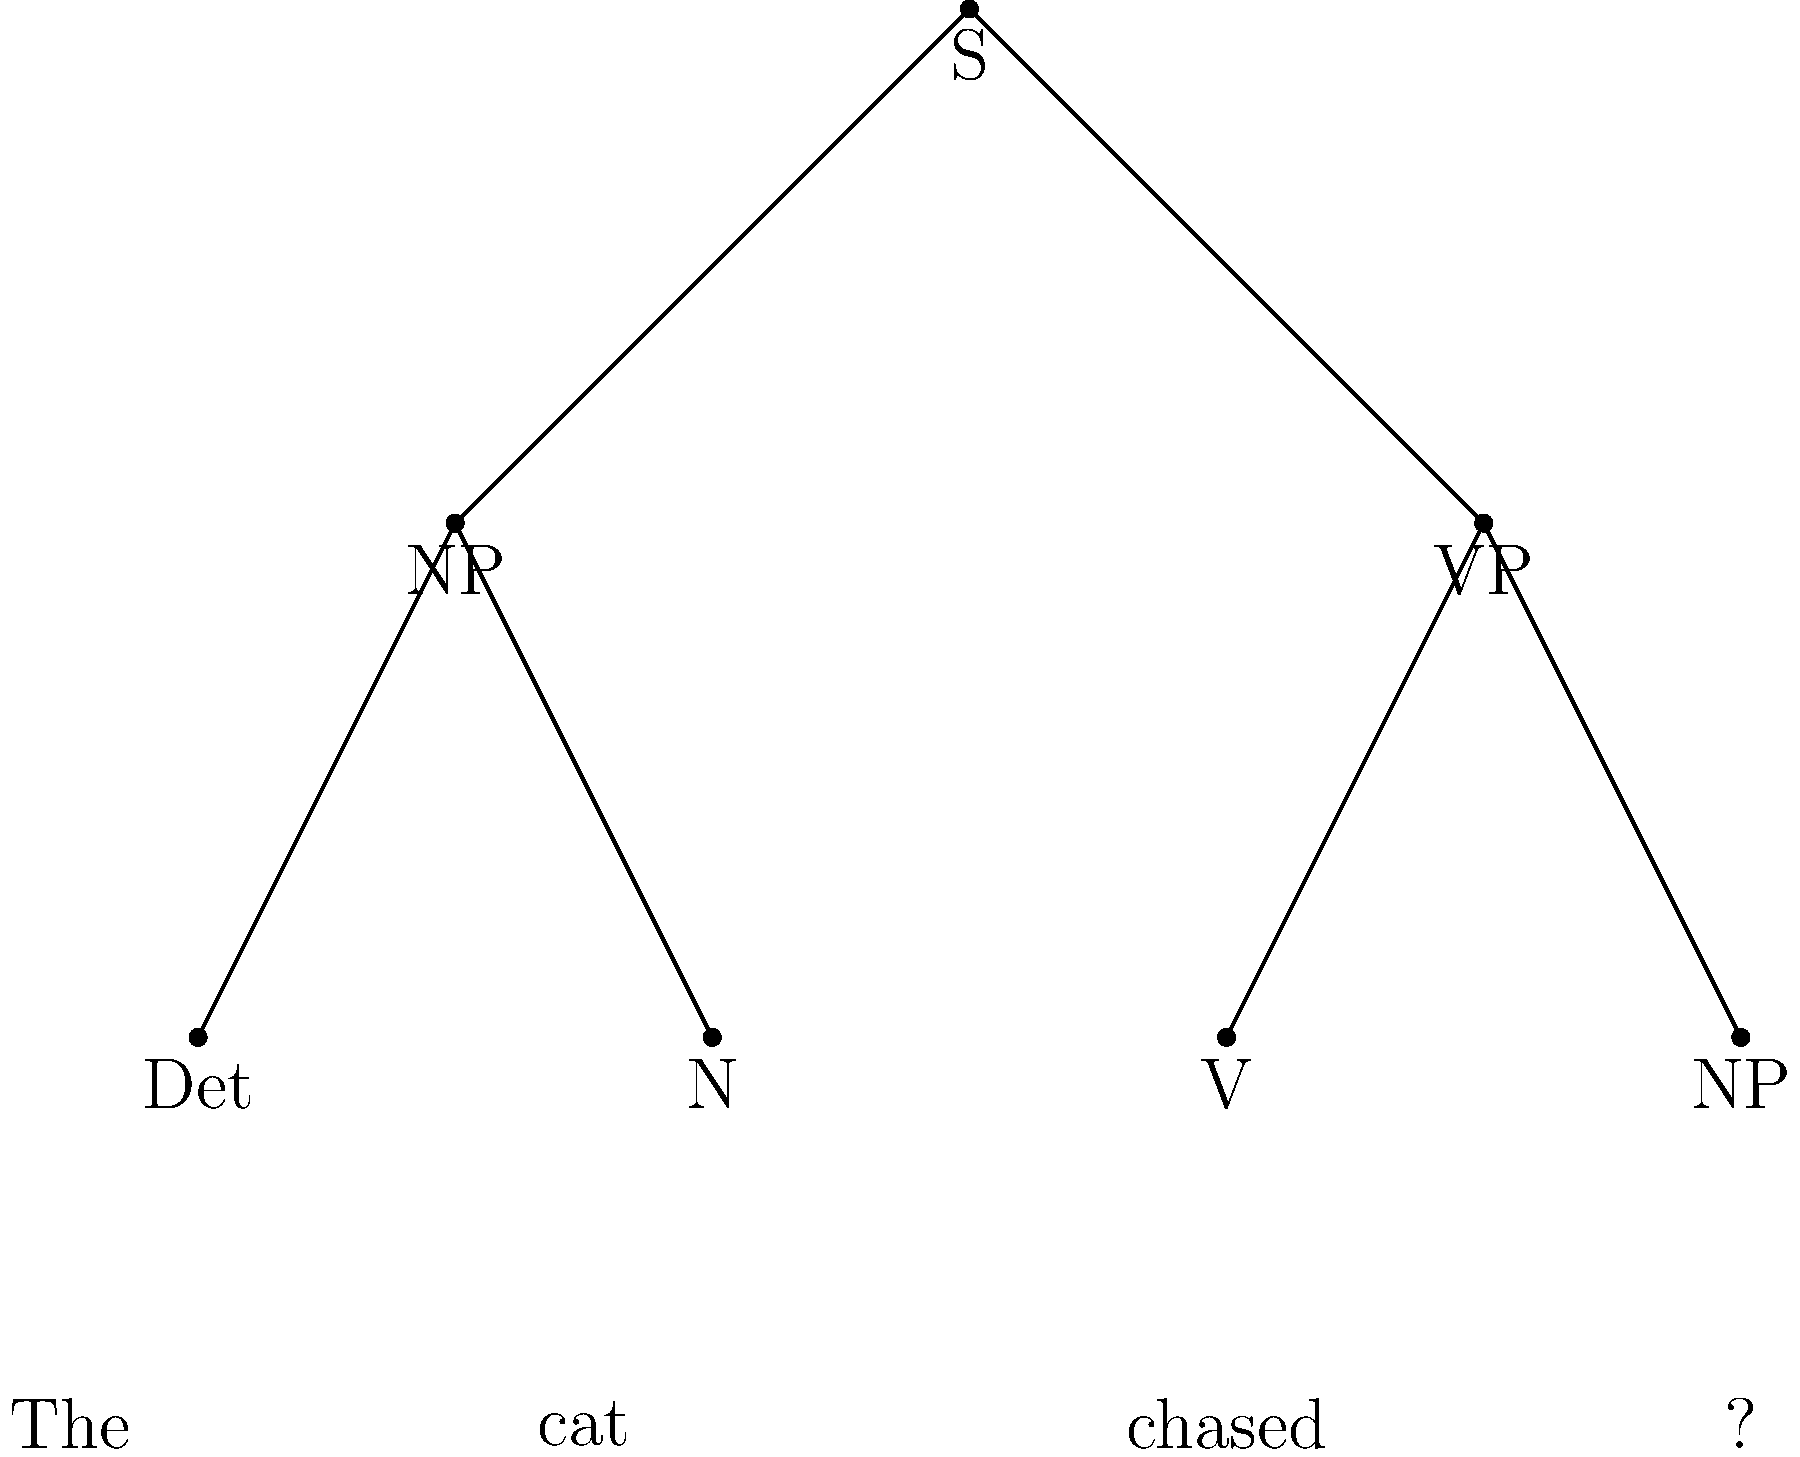Complete the parse tree for the sentence "The cat chased the mouse" using the given context-free grammar:

$S \rightarrow NP \space VP$
$NP \rightarrow Det \space N$
$VP \rightarrow V \space NP$
$Det \rightarrow \text{the} \space | \space \text{a}$
$N \rightarrow \text{cat} \space | \space \text{mouse}$
$V \rightarrow \text{chased}$

What should replace the question mark in the parse tree? To complete the parse tree, we need to follow these steps:

1. The root node S is already split into NP and VP, which is correct according to the first rule: $S \rightarrow NP \space VP$

2. The left NP is correctly expanded to Det and N, following the rule: $NP \rightarrow Det \space N$

3. The VP is correctly expanded to V and NP, following the rule: $VP \rightarrow V \space NP$

4. The terminal nodes "The", "cat", and "chased" are correctly placed.

5. The remaining NP under VP needs to be expanded further to complete the sentence "The cat chased the mouse".

6. According to the rule $NP \rightarrow Det \space N$, this NP should be expanded to Det and N.

7. The question mark in the parse tree represents the Det node for this NP.

8. The only remaining word in the sentence is "mouse", which will be the N node.

9. The Det for "mouse" must be "the" according to the given sentence.

Therefore, the question mark should be replaced with "Det", and below it should be the terminal node "the".
Answer: Det 